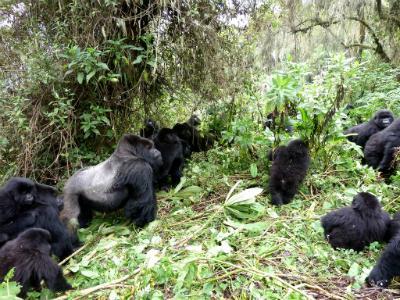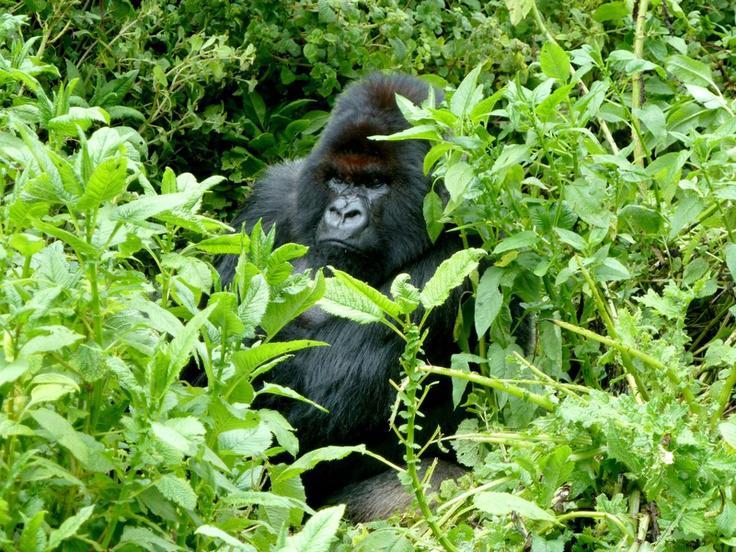The first image is the image on the left, the second image is the image on the right. For the images displayed, is the sentence "The left image contains exactly one gorilla." factually correct? Answer yes or no. No. The first image is the image on the left, the second image is the image on the right. Given the left and right images, does the statement "There are two gorillas in the pair of images." hold true? Answer yes or no. No. 